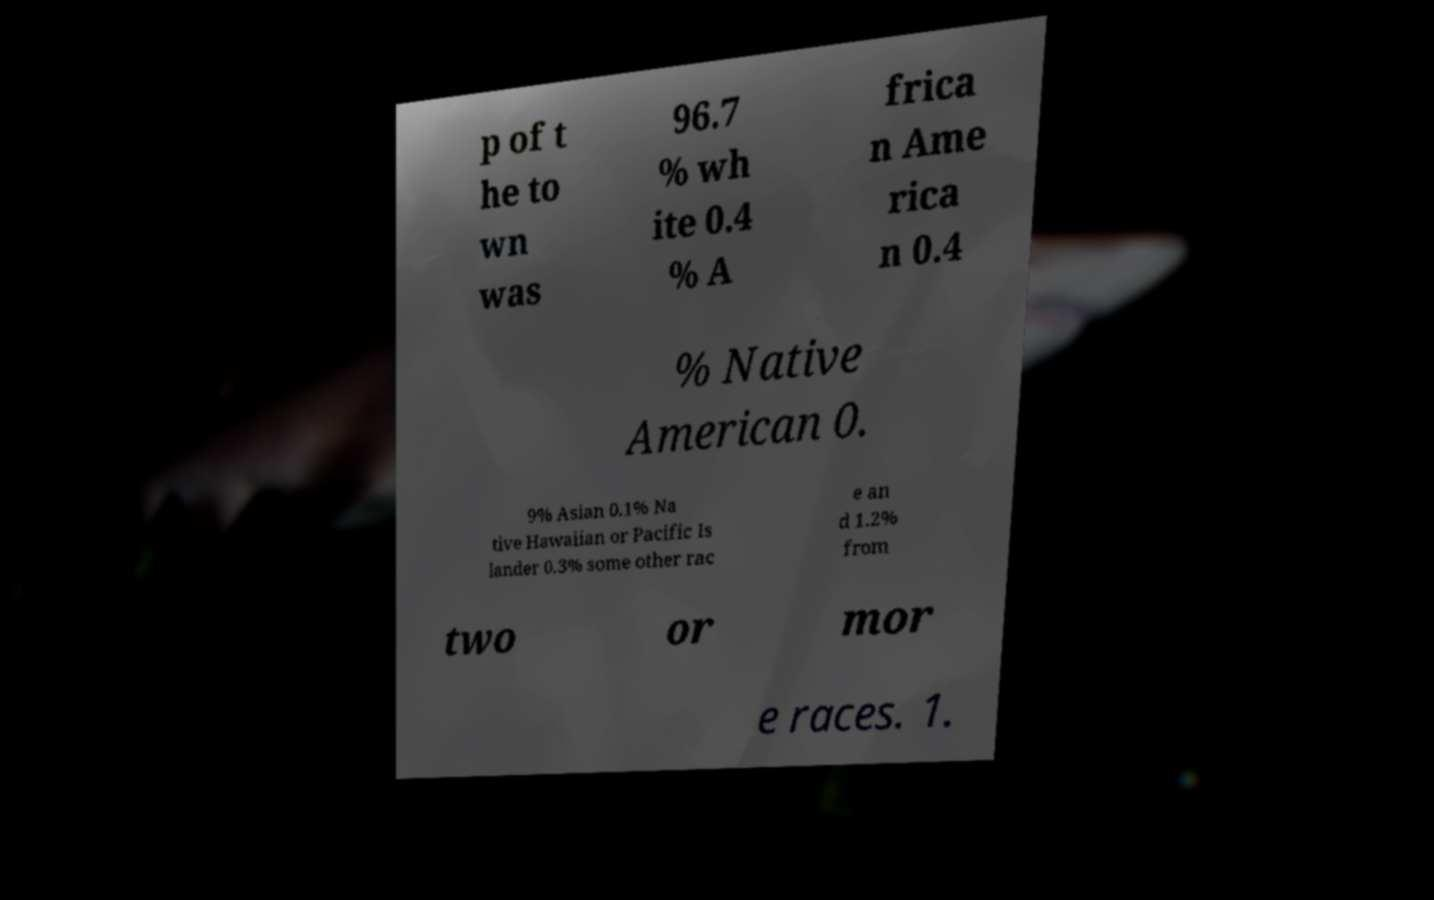Can you read and provide the text displayed in the image?This photo seems to have some interesting text. Can you extract and type it out for me? p of t he to wn was 96.7 % wh ite 0.4 % A frica n Ame rica n 0.4 % Native American 0. 9% Asian 0.1% Na tive Hawaiian or Pacific Is lander 0.3% some other rac e an d 1.2% from two or mor e races. 1. 